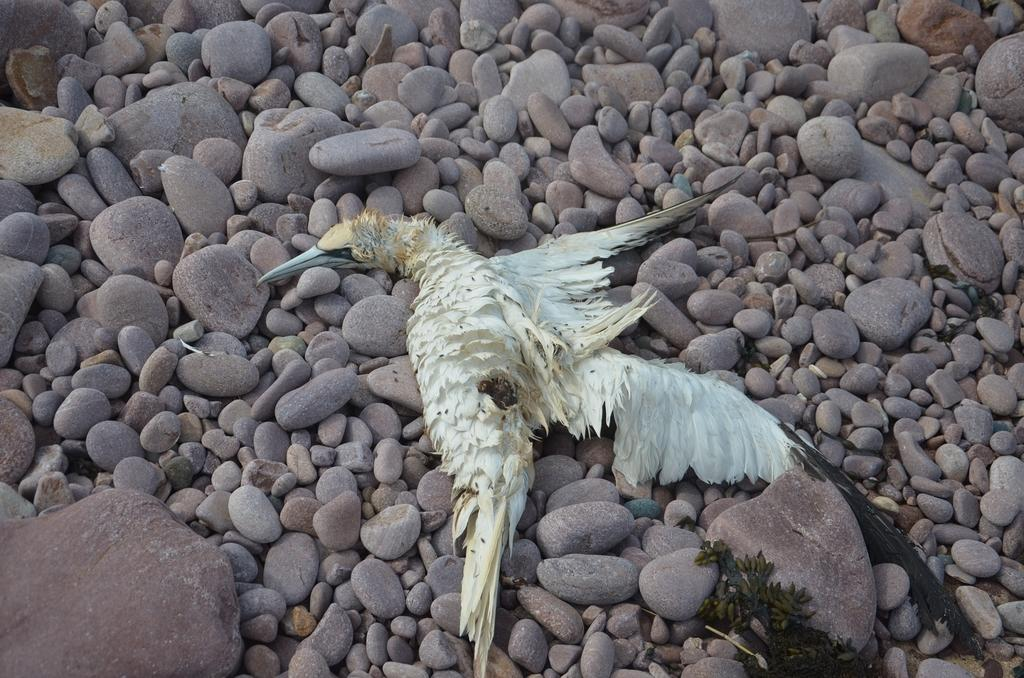What type of animal can be seen in the image? There is a bird in the image. What color is the bird? The bird is white in color. What is the bird lying on? The bird is lying on stones. What type of distribution system is being used by the bird in the image? There is no distribution system present in the image; it features a white bird lying on stones. 